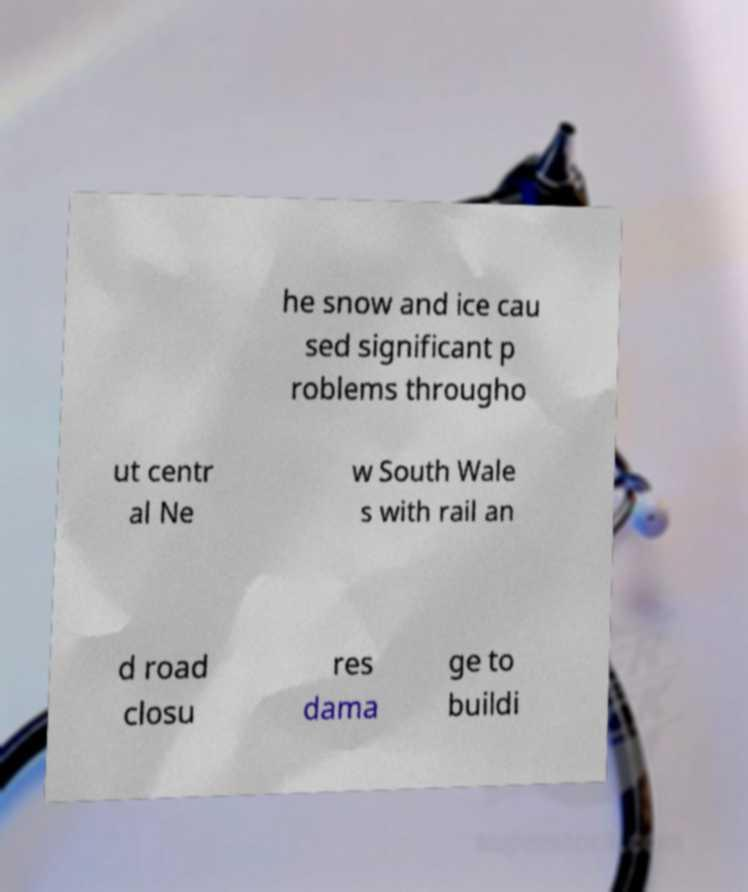Please read and relay the text visible in this image. What does it say? he snow and ice cau sed significant p roblems througho ut centr al Ne w South Wale s with rail an d road closu res dama ge to buildi 